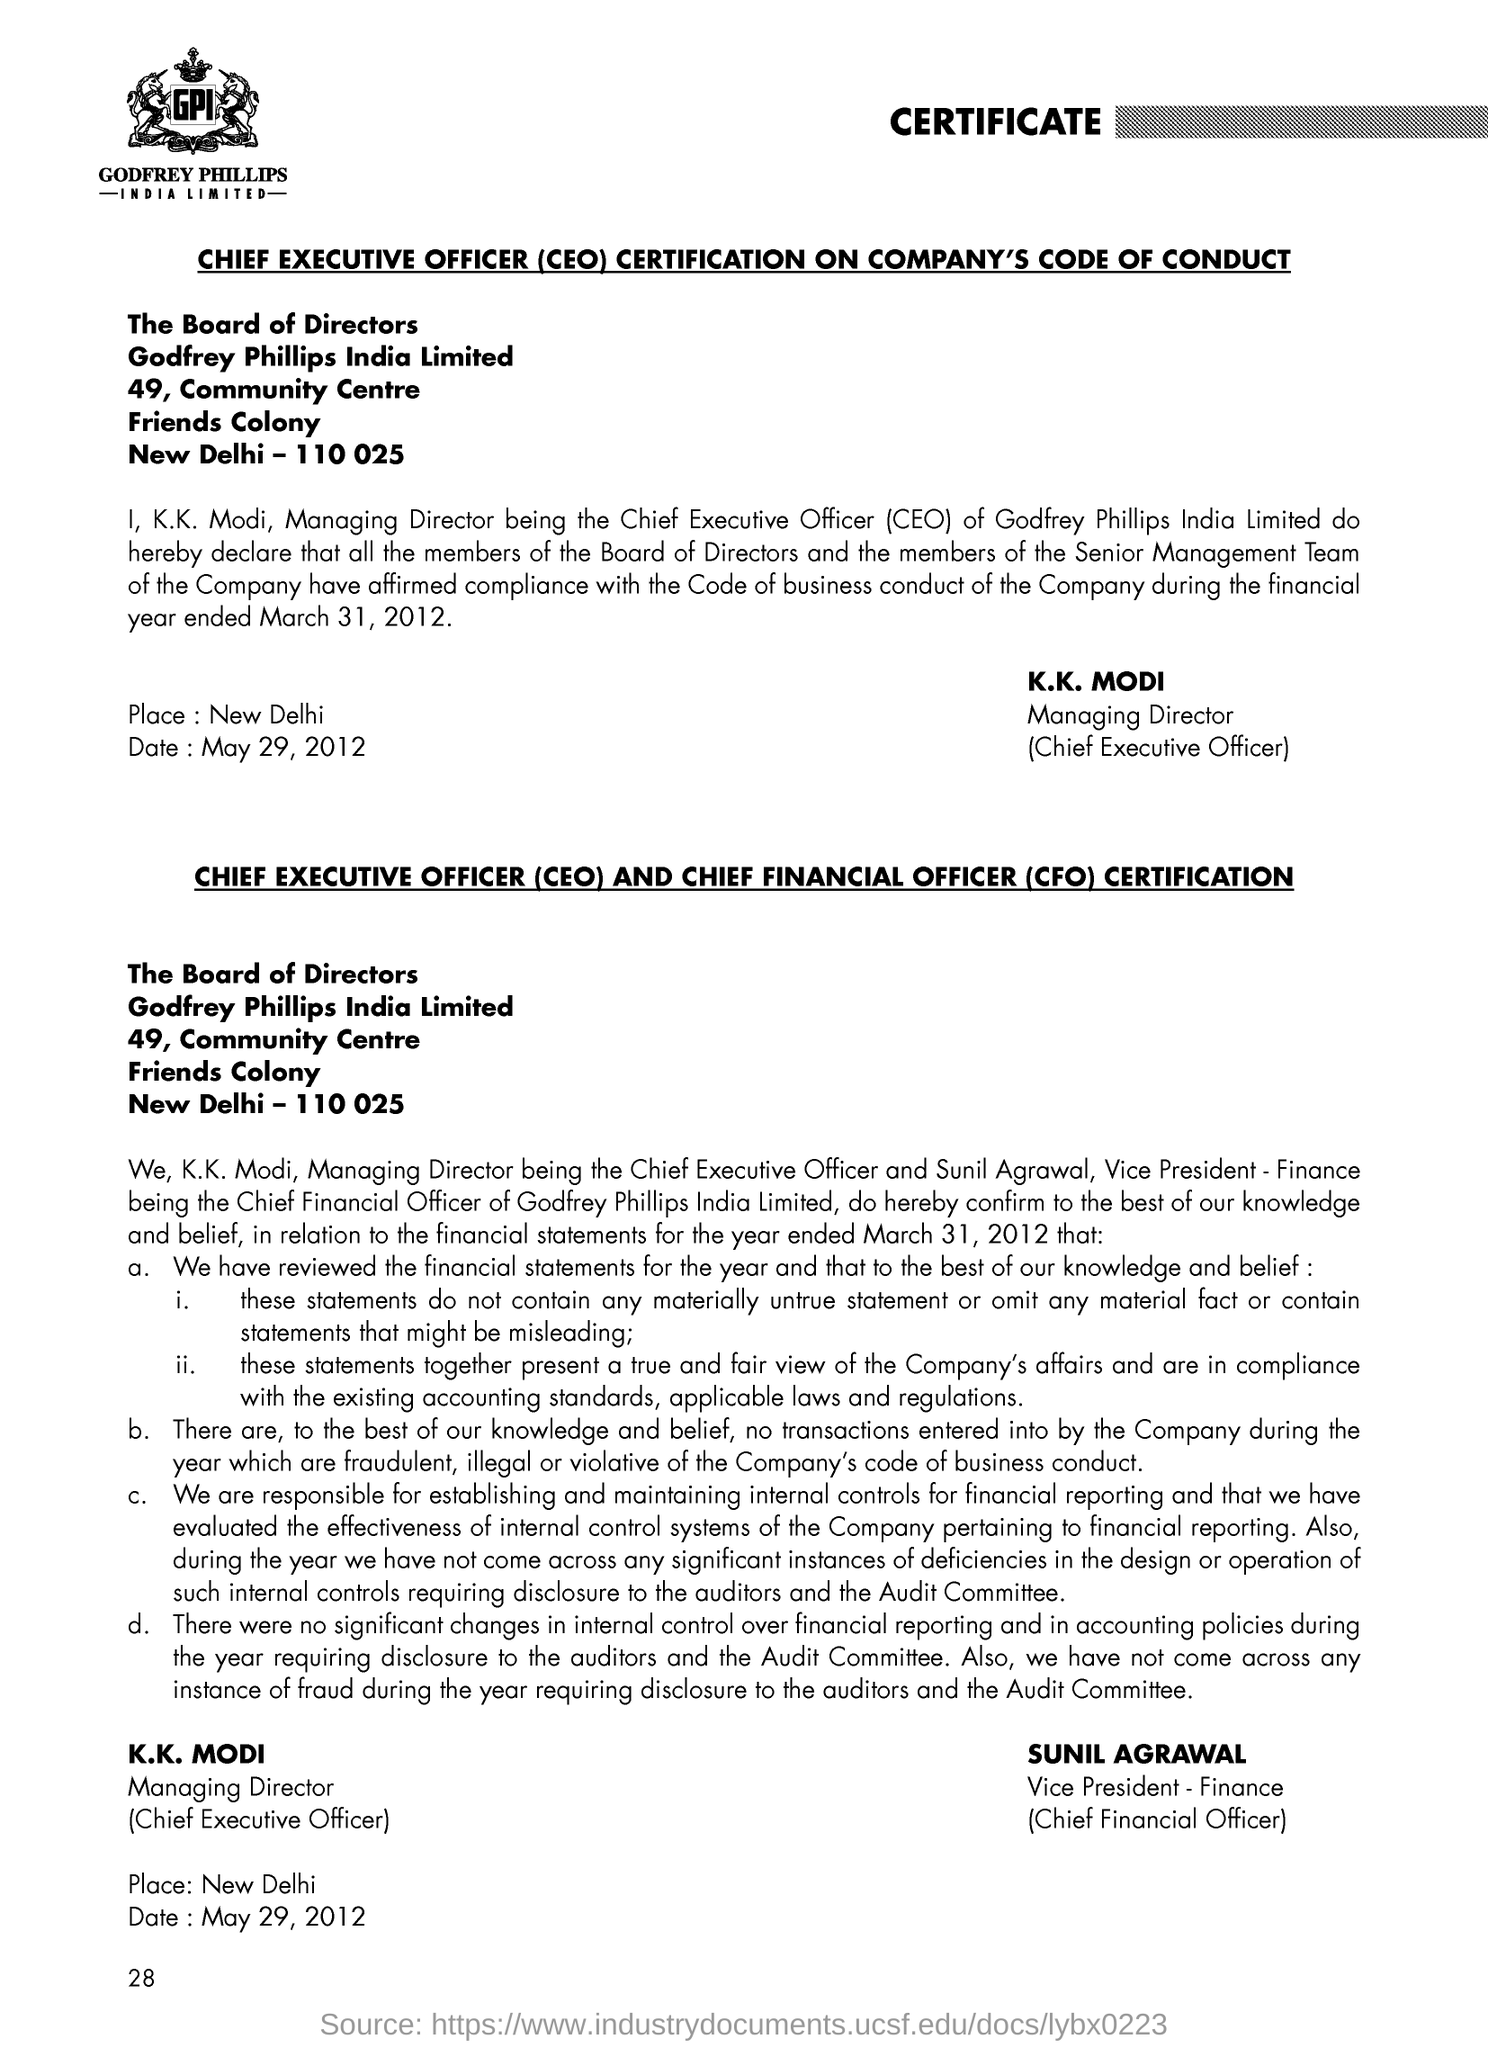What is the date mentioned ?
Your answer should be very brief. May 29, 2012. What is the full form of ceo
Offer a very short reply. Chief executive officer. What is the full form of cfo ?
Your answer should be very brief. Chief Financial officer. 